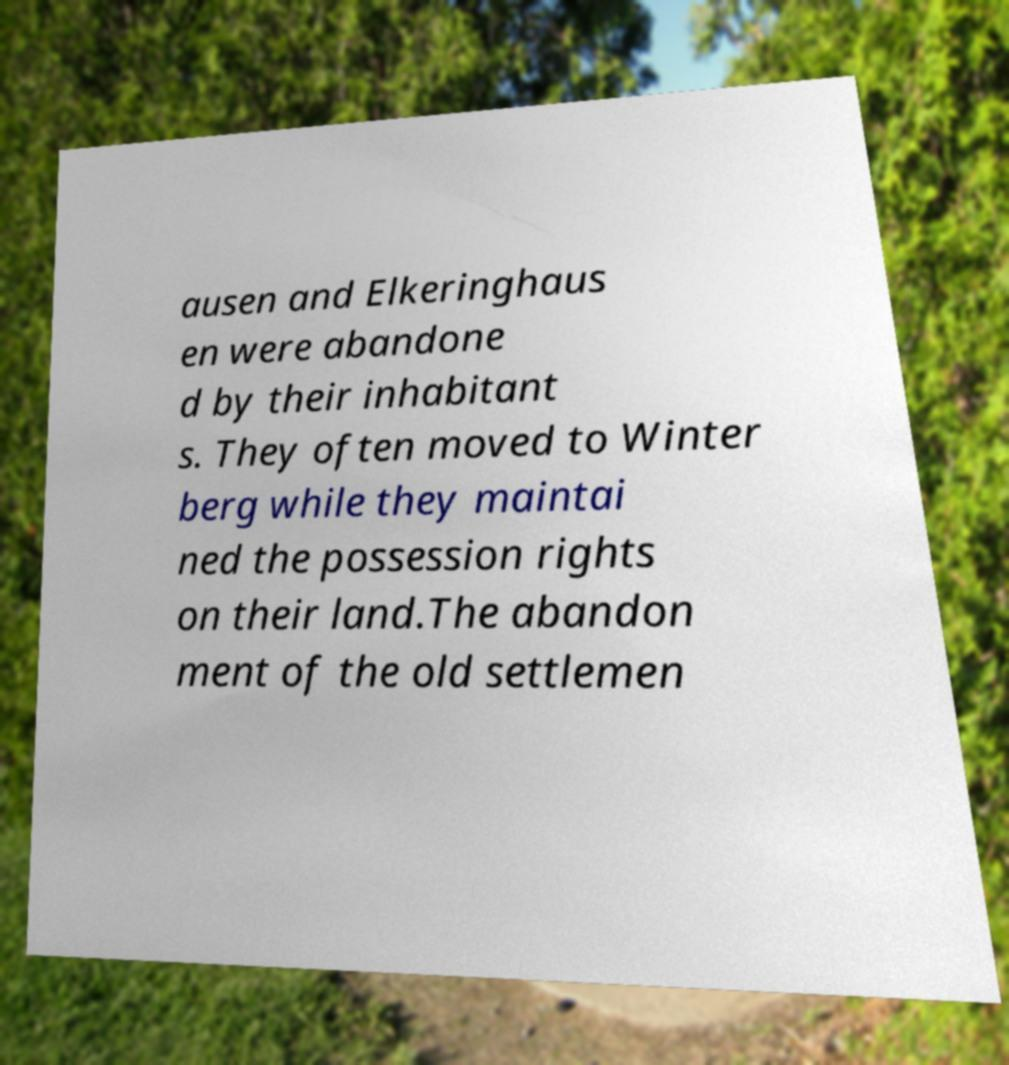Please identify and transcribe the text found in this image. ausen and Elkeringhaus en were abandone d by their inhabitant s. They often moved to Winter berg while they maintai ned the possession rights on their land.The abandon ment of the old settlemen 